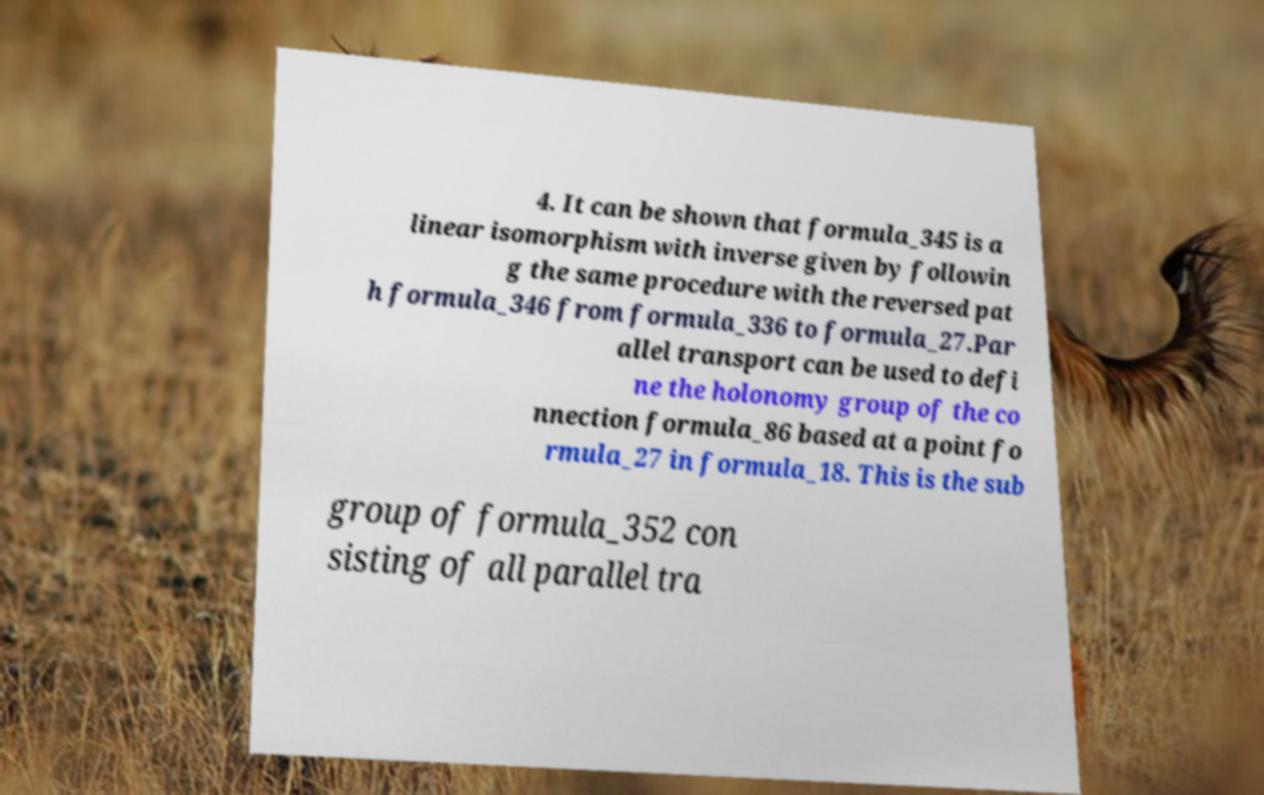Please identify and transcribe the text found in this image. 4. It can be shown that formula_345 is a linear isomorphism with inverse given by followin g the same procedure with the reversed pat h formula_346 from formula_336 to formula_27.Par allel transport can be used to defi ne the holonomy group of the co nnection formula_86 based at a point fo rmula_27 in formula_18. This is the sub group of formula_352 con sisting of all parallel tra 